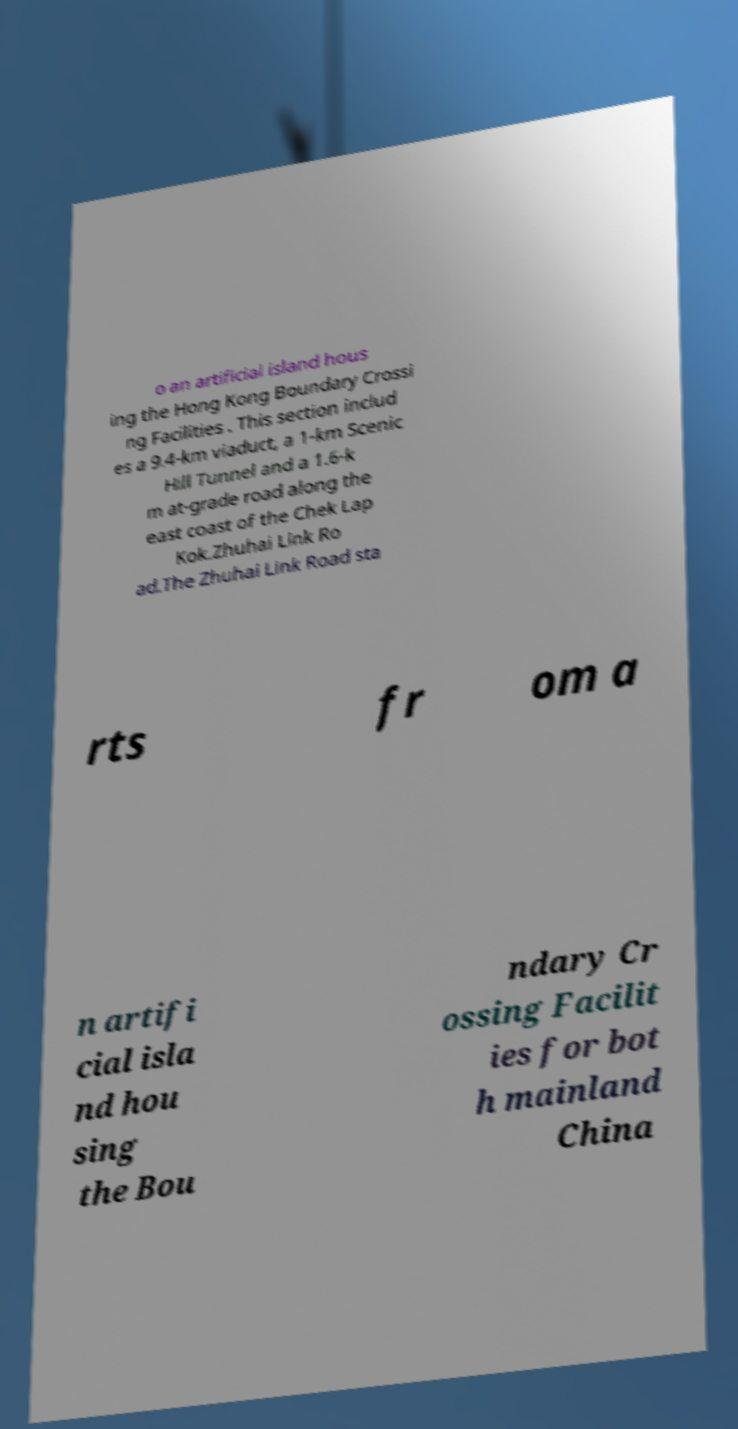For documentation purposes, I need the text within this image transcribed. Could you provide that? o an artificial island hous ing the Hong Kong Boundary Crossi ng Facilities . This section includ es a 9.4-km viaduct, a 1-km Scenic Hill Tunnel and a 1.6-k m at-grade road along the east coast of the Chek Lap Kok.Zhuhai Link Ro ad.The Zhuhai Link Road sta rts fr om a n artifi cial isla nd hou sing the Bou ndary Cr ossing Facilit ies for bot h mainland China 